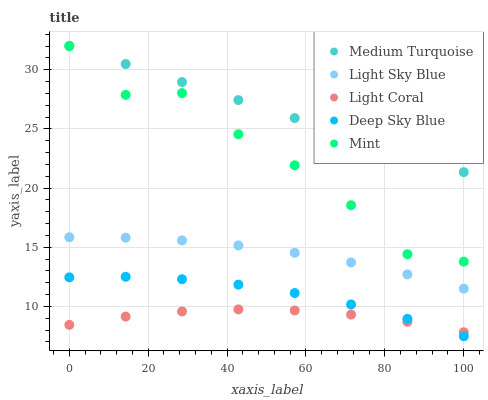Does Light Coral have the minimum area under the curve?
Answer yes or no. Yes. Does Medium Turquoise have the maximum area under the curve?
Answer yes or no. Yes. Does Light Sky Blue have the minimum area under the curve?
Answer yes or no. No. Does Light Sky Blue have the maximum area under the curve?
Answer yes or no. No. Is Medium Turquoise the smoothest?
Answer yes or no. Yes. Is Mint the roughest?
Answer yes or no. Yes. Is Light Sky Blue the smoothest?
Answer yes or no. No. Is Light Sky Blue the roughest?
Answer yes or no. No. Does Deep Sky Blue have the lowest value?
Answer yes or no. Yes. Does Light Sky Blue have the lowest value?
Answer yes or no. No. Does Medium Turquoise have the highest value?
Answer yes or no. Yes. Does Light Sky Blue have the highest value?
Answer yes or no. No. Is Deep Sky Blue less than Mint?
Answer yes or no. Yes. Is Light Sky Blue greater than Deep Sky Blue?
Answer yes or no. Yes. Does Light Coral intersect Deep Sky Blue?
Answer yes or no. Yes. Is Light Coral less than Deep Sky Blue?
Answer yes or no. No. Is Light Coral greater than Deep Sky Blue?
Answer yes or no. No. Does Deep Sky Blue intersect Mint?
Answer yes or no. No. 